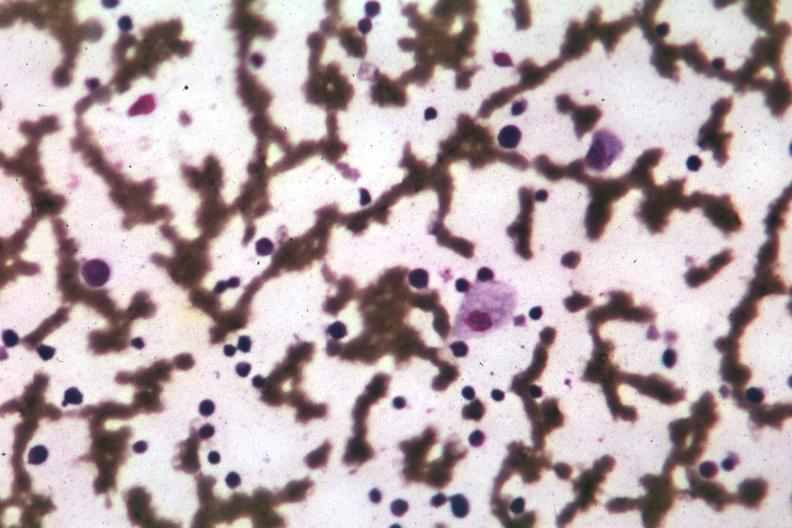s hematologic present?
Answer the question using a single word or phrase. Yes 